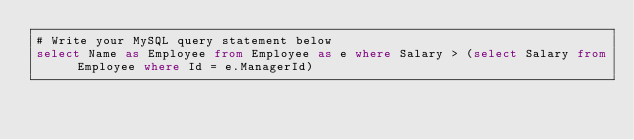Convert code to text. <code><loc_0><loc_0><loc_500><loc_500><_SQL_># Write your MySQL query statement below
select Name as Employee from Employee as e where Salary > (select Salary from Employee where Id = e.ManagerId)</code> 